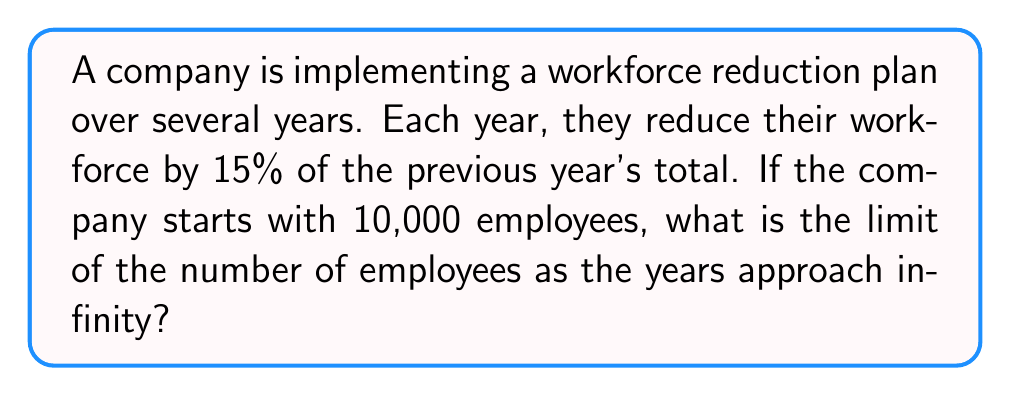Solve this math problem. Let's approach this step-by-step:

1) First, we need to recognize this as a geometric series. The common ratio is $r = 1 - 0.15 = 0.85$, as each year the workforce is 85% of the previous year.

2) The initial term $a_1 = 10,000$ employees.

3) The general term of this geometric sequence is:

   $a_n = 10,000 \cdot (0.85)^{n-1}$

4) For a geometric series, if $|r| < 1$, the series converges, and the limit as $n$ approaches infinity is given by:

   $\lim_{n \to \infty} S_n = \frac{a_1}{1-r}$

5) In this case, $|r| = 0.85 < 1$, so the series converges.

6) Applying the formula:

   $\lim_{n \to \infty} S_n = \frac{10,000}{1-0.85}$

7) Simplifying:

   $\lim_{n \to \infty} S_n = \frac{10,000}{0.15} = 66,666.67$

Therefore, as the years approach infinity, the number of employees approaches 66,666.67, or approximately 66,667 employees.
Answer: 66,667 employees 